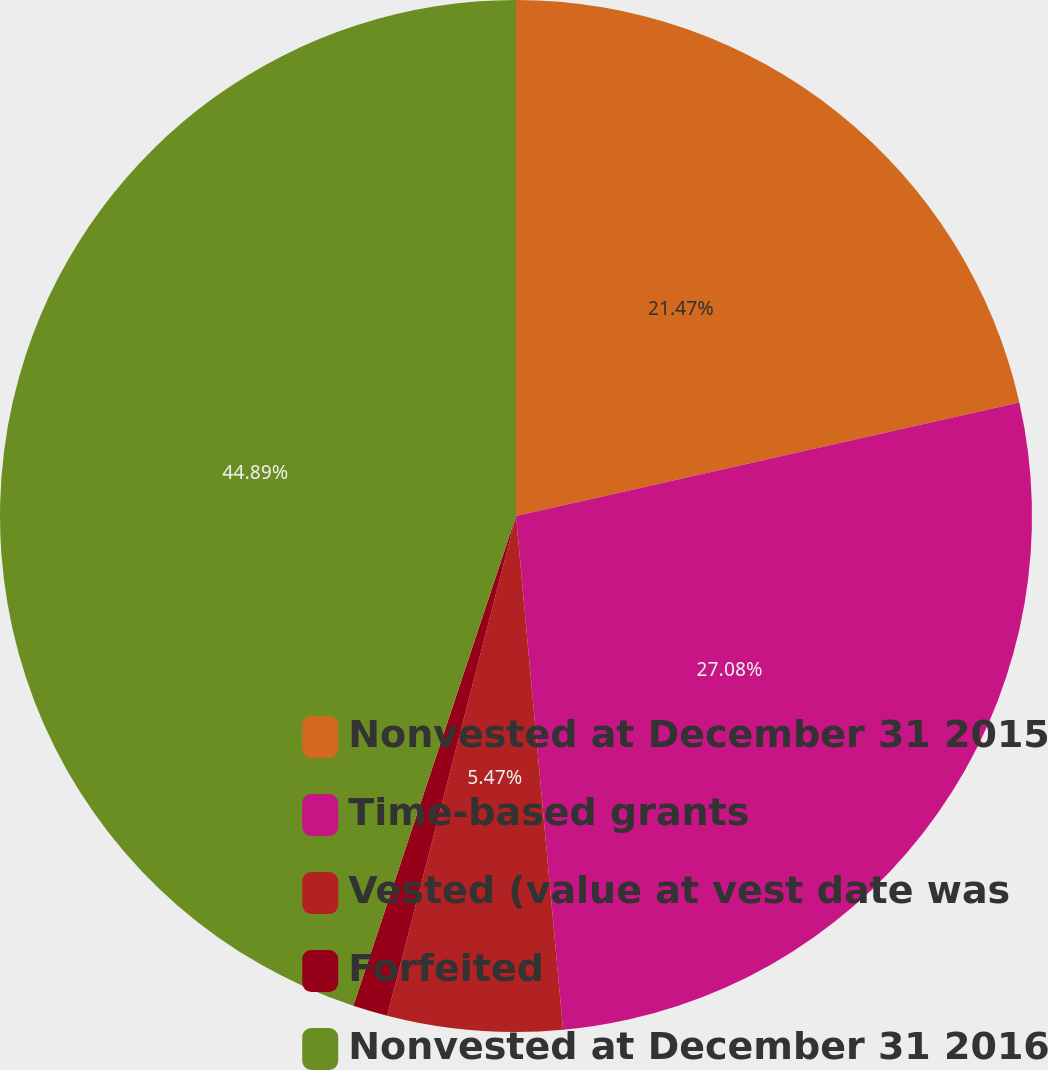Convert chart. <chart><loc_0><loc_0><loc_500><loc_500><pie_chart><fcel>Nonvested at December 31 2015<fcel>Time-based grants<fcel>Vested (value at vest date was<fcel>Forfeited<fcel>Nonvested at December 31 2016<nl><fcel>21.47%<fcel>27.08%<fcel>5.47%<fcel>1.09%<fcel>44.9%<nl></chart> 